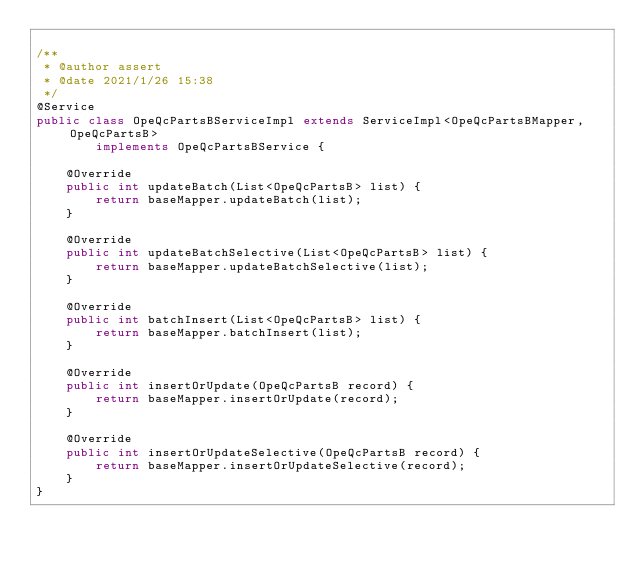<code> <loc_0><loc_0><loc_500><loc_500><_Java_>
/**
 * @author assert
 * @date 2021/1/26 15:38
 */
@Service
public class OpeQcPartsBServiceImpl extends ServiceImpl<OpeQcPartsBMapper, OpeQcPartsB>
        implements OpeQcPartsBService {

    @Override
    public int updateBatch(List<OpeQcPartsB> list) {
        return baseMapper.updateBatch(list);
    }

    @Override
    public int updateBatchSelective(List<OpeQcPartsB> list) {
        return baseMapper.updateBatchSelective(list);
    }

    @Override
    public int batchInsert(List<OpeQcPartsB> list) {
        return baseMapper.batchInsert(list);
    }

    @Override
    public int insertOrUpdate(OpeQcPartsB record) {
        return baseMapper.insertOrUpdate(record);
    }

    @Override
    public int insertOrUpdateSelective(OpeQcPartsB record) {
        return baseMapper.insertOrUpdateSelective(record);
    }
}


</code> 